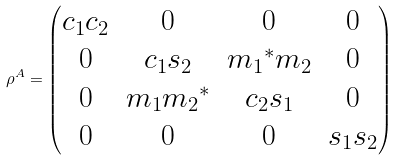Convert formula to latex. <formula><loc_0><loc_0><loc_500><loc_500>\rho ^ { A } = \begin{pmatrix} c _ { 1 } c _ { 2 } & 0 & 0 & 0 \\ 0 & c _ { 1 } s _ { 2 } & { m _ { 1 } } ^ { * } m _ { 2 } & 0 \\ 0 & m _ { 1 } { m _ { 2 } } ^ { * } & c _ { 2 } s _ { 1 } & 0 \\ 0 & 0 & 0 & s _ { 1 } s _ { 2 } \\ \end{pmatrix}</formula> 